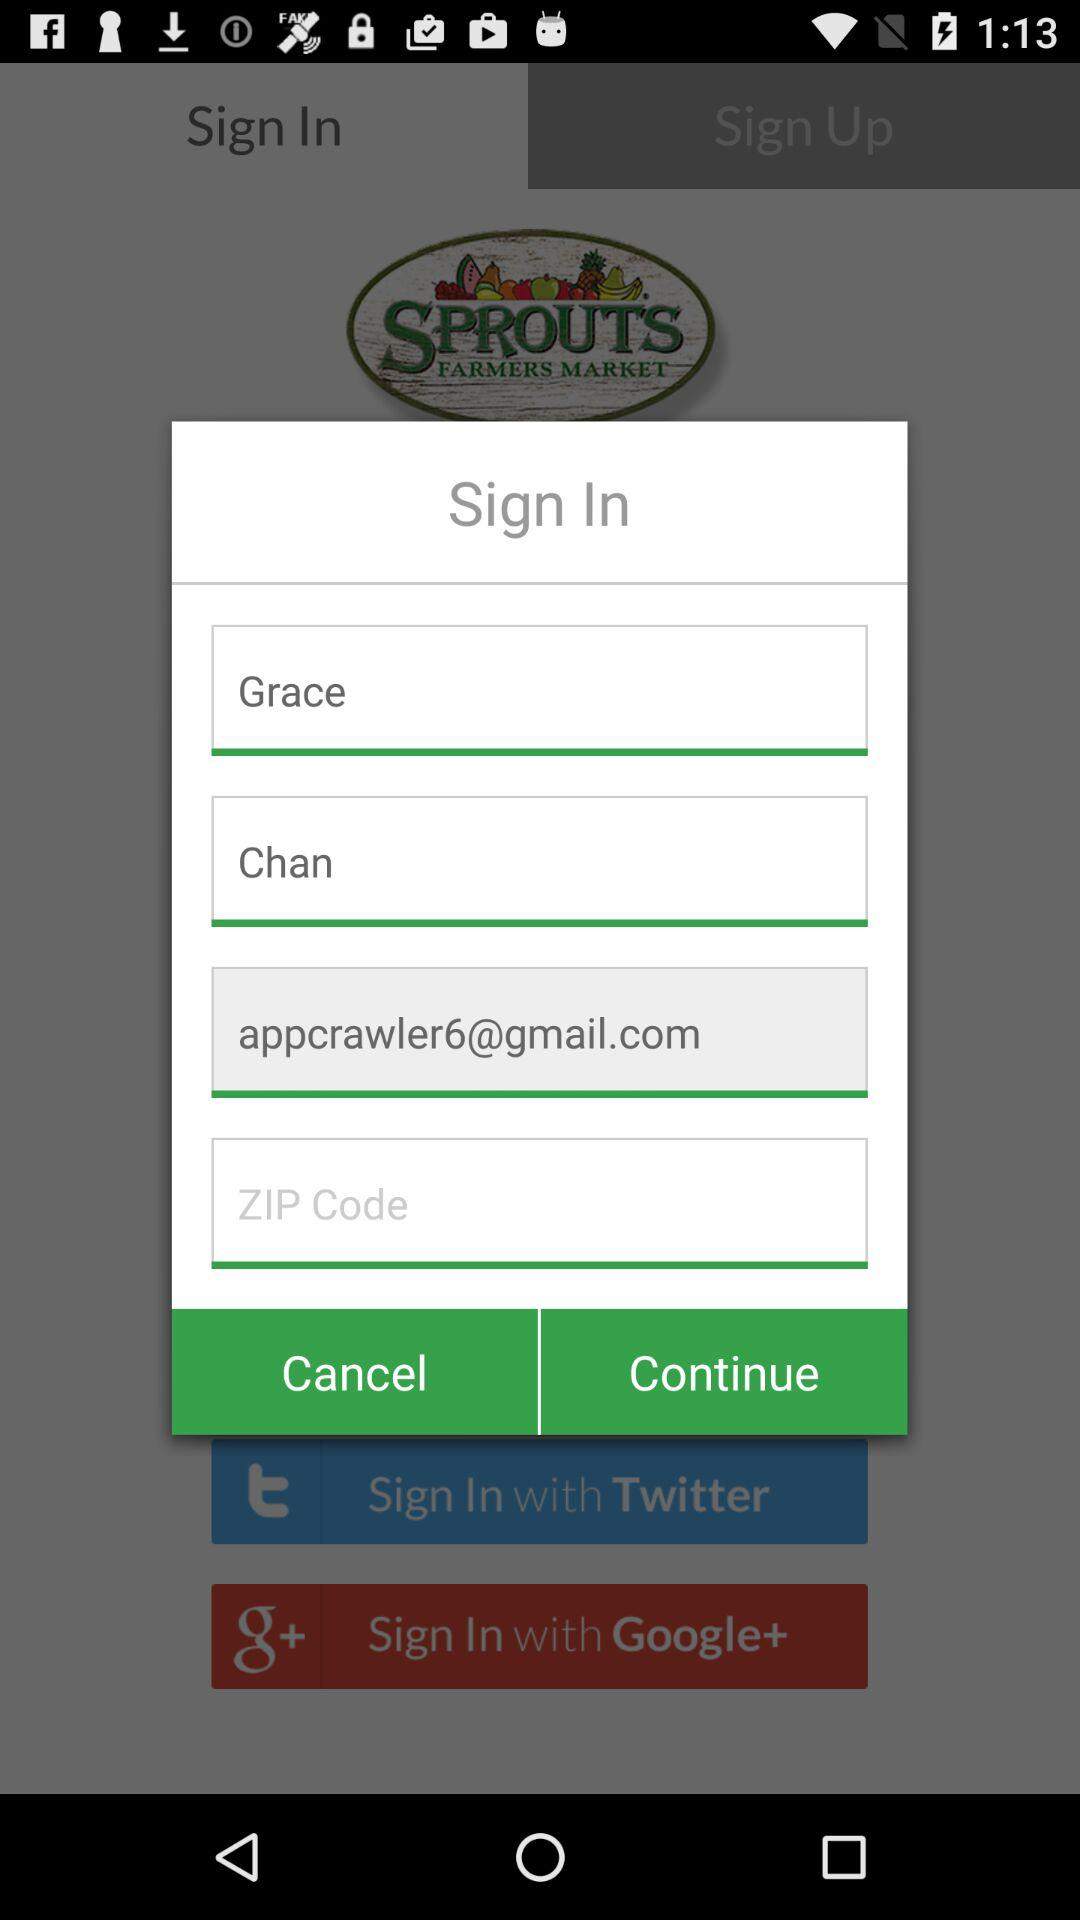Which tab is currently open? The currently open tab is "Sign In". 